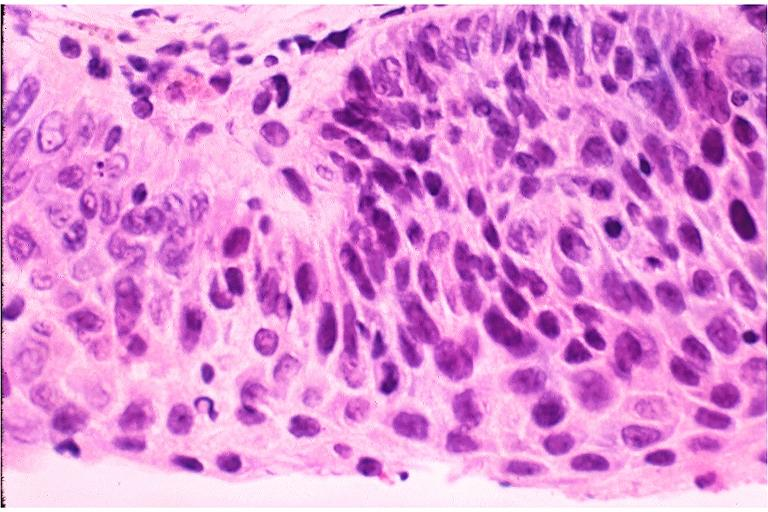what does this image show?
Answer the question using a single word or phrase. Severe epithelial dysplasia 